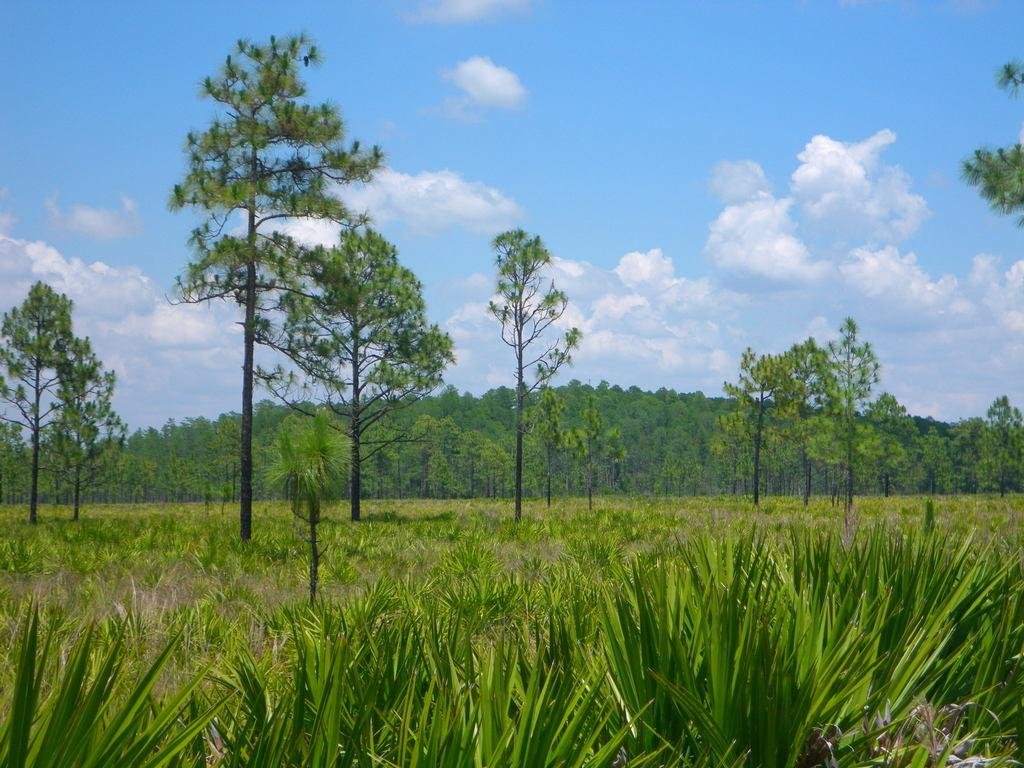What type of vegetation can be seen in the image? There is grass in the image. What other natural elements are present in the image? There are trees in the image. What is visible in the background of the image? The sky is visible in the image. What can be observed in the sky? Clouds are present in the sky. What type of hair can be seen on the trees in the image? There is no hair present on the trees in the image; they are natural vegetation. 